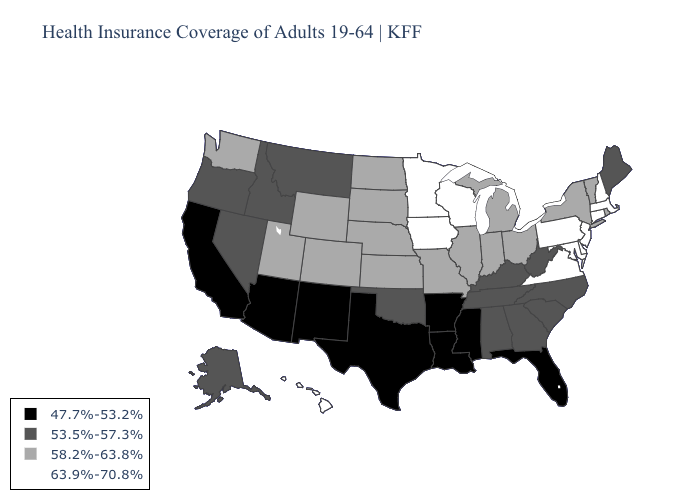Name the states that have a value in the range 63.9%-70.8%?
Be succinct. Connecticut, Delaware, Hawaii, Iowa, Maryland, Massachusetts, Minnesota, New Hampshire, New Jersey, Pennsylvania, Virginia, Wisconsin. Name the states that have a value in the range 63.9%-70.8%?
Short answer required. Connecticut, Delaware, Hawaii, Iowa, Maryland, Massachusetts, Minnesota, New Hampshire, New Jersey, Pennsylvania, Virginia, Wisconsin. Among the states that border Kentucky , does West Virginia have the highest value?
Short answer required. No. Which states hav the highest value in the South?
Write a very short answer. Delaware, Maryland, Virginia. Name the states that have a value in the range 63.9%-70.8%?
Give a very brief answer. Connecticut, Delaware, Hawaii, Iowa, Maryland, Massachusetts, Minnesota, New Hampshire, New Jersey, Pennsylvania, Virginia, Wisconsin. Name the states that have a value in the range 47.7%-53.2%?
Be succinct. Arizona, Arkansas, California, Florida, Louisiana, Mississippi, New Mexico, Texas. Which states have the highest value in the USA?
Answer briefly. Connecticut, Delaware, Hawaii, Iowa, Maryland, Massachusetts, Minnesota, New Hampshire, New Jersey, Pennsylvania, Virginia, Wisconsin. What is the highest value in the Northeast ?
Concise answer only. 63.9%-70.8%. What is the value of Maine?
Give a very brief answer. 53.5%-57.3%. What is the highest value in states that border Arkansas?
Quick response, please. 58.2%-63.8%. Name the states that have a value in the range 53.5%-57.3%?
Give a very brief answer. Alabama, Alaska, Georgia, Idaho, Kentucky, Maine, Montana, Nevada, North Carolina, Oklahoma, Oregon, South Carolina, Tennessee, West Virginia. Name the states that have a value in the range 47.7%-53.2%?
Be succinct. Arizona, Arkansas, California, Florida, Louisiana, Mississippi, New Mexico, Texas. What is the highest value in states that border New Hampshire?
Short answer required. 63.9%-70.8%. What is the value of Arizona?
Give a very brief answer. 47.7%-53.2%. Does Massachusetts have the highest value in the USA?
Give a very brief answer. Yes. 